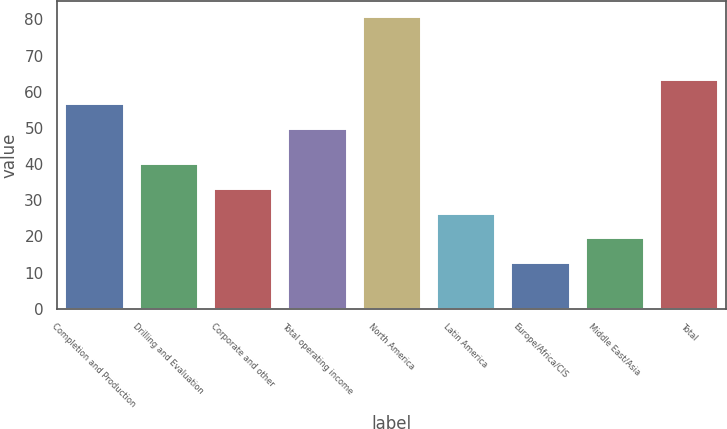<chart> <loc_0><loc_0><loc_500><loc_500><bar_chart><fcel>Completion and Production<fcel>Drilling and Evaluation<fcel>Corporate and other<fcel>Total operating income<fcel>North America<fcel>Latin America<fcel>Europe/Africa/CIS<fcel>Middle East/Asia<fcel>Total<nl><fcel>56.8<fcel>40.2<fcel>33.4<fcel>50<fcel>81<fcel>26.6<fcel>13<fcel>19.8<fcel>63.6<nl></chart> 